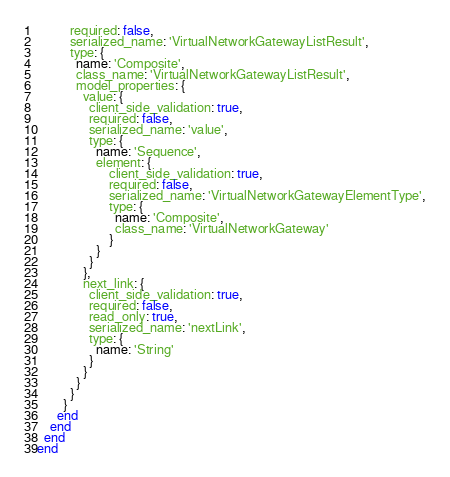Convert code to text. <code><loc_0><loc_0><loc_500><loc_500><_Ruby_>          required: false,
          serialized_name: 'VirtualNetworkGatewayListResult',
          type: {
            name: 'Composite',
            class_name: 'VirtualNetworkGatewayListResult',
            model_properties: {
              value: {
                client_side_validation: true,
                required: false,
                serialized_name: 'value',
                type: {
                  name: 'Sequence',
                  element: {
                      client_side_validation: true,
                      required: false,
                      serialized_name: 'VirtualNetworkGatewayElementType',
                      type: {
                        name: 'Composite',
                        class_name: 'VirtualNetworkGateway'
                      }
                  }
                }
              },
              next_link: {
                client_side_validation: true,
                required: false,
                read_only: true,
                serialized_name: 'nextLink',
                type: {
                  name: 'String'
                }
              }
            }
          }
        }
      end
    end
  end
end
</code> 